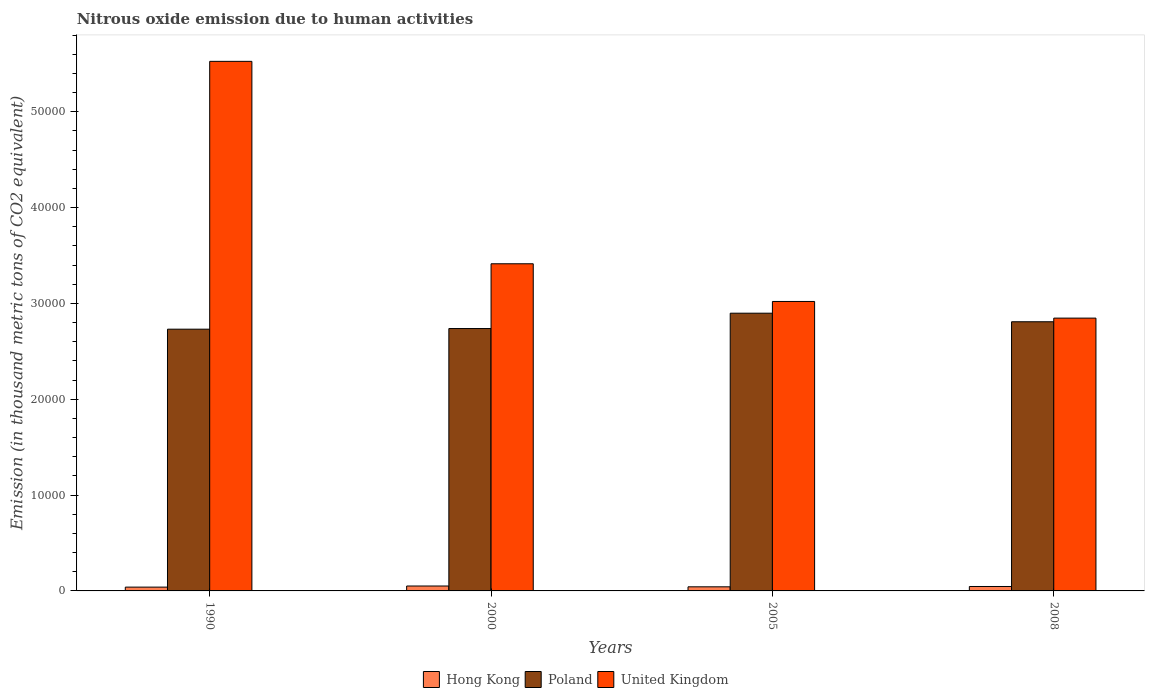How many different coloured bars are there?
Give a very brief answer. 3. Are the number of bars per tick equal to the number of legend labels?
Provide a short and direct response. Yes. Are the number of bars on each tick of the X-axis equal?
Offer a terse response. Yes. What is the label of the 3rd group of bars from the left?
Keep it short and to the point. 2005. What is the amount of nitrous oxide emitted in Hong Kong in 2008?
Your answer should be very brief. 462.8. Across all years, what is the maximum amount of nitrous oxide emitted in Hong Kong?
Make the answer very short. 513.2. Across all years, what is the minimum amount of nitrous oxide emitted in Hong Kong?
Provide a succinct answer. 396.9. In which year was the amount of nitrous oxide emitted in United Kingdom maximum?
Your answer should be compact. 1990. What is the total amount of nitrous oxide emitted in Hong Kong in the graph?
Your answer should be compact. 1801.1. What is the difference between the amount of nitrous oxide emitted in Hong Kong in 1990 and that in 2000?
Keep it short and to the point. -116.3. What is the difference between the amount of nitrous oxide emitted in Hong Kong in 2000 and the amount of nitrous oxide emitted in Poland in 1990?
Provide a succinct answer. -2.68e+04. What is the average amount of nitrous oxide emitted in Hong Kong per year?
Provide a succinct answer. 450.27. In the year 2005, what is the difference between the amount of nitrous oxide emitted in Hong Kong and amount of nitrous oxide emitted in United Kingdom?
Keep it short and to the point. -2.98e+04. In how many years, is the amount of nitrous oxide emitted in Poland greater than 22000 thousand metric tons?
Make the answer very short. 4. What is the ratio of the amount of nitrous oxide emitted in Poland in 1990 to that in 2005?
Offer a terse response. 0.94. Is the difference between the amount of nitrous oxide emitted in Hong Kong in 1990 and 2008 greater than the difference between the amount of nitrous oxide emitted in United Kingdom in 1990 and 2008?
Provide a succinct answer. No. What is the difference between the highest and the second highest amount of nitrous oxide emitted in Hong Kong?
Offer a terse response. 50.4. What is the difference between the highest and the lowest amount of nitrous oxide emitted in Poland?
Give a very brief answer. 1667.4. Is the sum of the amount of nitrous oxide emitted in Hong Kong in 1990 and 2000 greater than the maximum amount of nitrous oxide emitted in United Kingdom across all years?
Give a very brief answer. No. What does the 1st bar from the left in 2008 represents?
Make the answer very short. Hong Kong. What does the 3rd bar from the right in 2000 represents?
Ensure brevity in your answer.  Hong Kong. Are all the bars in the graph horizontal?
Provide a succinct answer. No. What is the difference between two consecutive major ticks on the Y-axis?
Keep it short and to the point. 10000. Does the graph contain any zero values?
Make the answer very short. No. Where does the legend appear in the graph?
Keep it short and to the point. Bottom center. What is the title of the graph?
Provide a succinct answer. Nitrous oxide emission due to human activities. Does "Pacific island small states" appear as one of the legend labels in the graph?
Keep it short and to the point. No. What is the label or title of the Y-axis?
Your answer should be compact. Emission (in thousand metric tons of CO2 equivalent). What is the Emission (in thousand metric tons of CO2 equivalent) of Hong Kong in 1990?
Provide a succinct answer. 396.9. What is the Emission (in thousand metric tons of CO2 equivalent) of Poland in 1990?
Your answer should be compact. 2.73e+04. What is the Emission (in thousand metric tons of CO2 equivalent) in United Kingdom in 1990?
Ensure brevity in your answer.  5.53e+04. What is the Emission (in thousand metric tons of CO2 equivalent) of Hong Kong in 2000?
Keep it short and to the point. 513.2. What is the Emission (in thousand metric tons of CO2 equivalent) in Poland in 2000?
Give a very brief answer. 2.74e+04. What is the Emission (in thousand metric tons of CO2 equivalent) of United Kingdom in 2000?
Your answer should be very brief. 3.41e+04. What is the Emission (in thousand metric tons of CO2 equivalent) in Hong Kong in 2005?
Give a very brief answer. 428.2. What is the Emission (in thousand metric tons of CO2 equivalent) in Poland in 2005?
Ensure brevity in your answer.  2.90e+04. What is the Emission (in thousand metric tons of CO2 equivalent) of United Kingdom in 2005?
Provide a succinct answer. 3.02e+04. What is the Emission (in thousand metric tons of CO2 equivalent) of Hong Kong in 2008?
Provide a succinct answer. 462.8. What is the Emission (in thousand metric tons of CO2 equivalent) of Poland in 2008?
Keep it short and to the point. 2.81e+04. What is the Emission (in thousand metric tons of CO2 equivalent) in United Kingdom in 2008?
Give a very brief answer. 2.85e+04. Across all years, what is the maximum Emission (in thousand metric tons of CO2 equivalent) in Hong Kong?
Make the answer very short. 513.2. Across all years, what is the maximum Emission (in thousand metric tons of CO2 equivalent) in Poland?
Offer a terse response. 2.90e+04. Across all years, what is the maximum Emission (in thousand metric tons of CO2 equivalent) in United Kingdom?
Make the answer very short. 5.53e+04. Across all years, what is the minimum Emission (in thousand metric tons of CO2 equivalent) of Hong Kong?
Your answer should be very brief. 396.9. Across all years, what is the minimum Emission (in thousand metric tons of CO2 equivalent) in Poland?
Give a very brief answer. 2.73e+04. Across all years, what is the minimum Emission (in thousand metric tons of CO2 equivalent) of United Kingdom?
Ensure brevity in your answer.  2.85e+04. What is the total Emission (in thousand metric tons of CO2 equivalent) in Hong Kong in the graph?
Your answer should be compact. 1801.1. What is the total Emission (in thousand metric tons of CO2 equivalent) of Poland in the graph?
Make the answer very short. 1.12e+05. What is the total Emission (in thousand metric tons of CO2 equivalent) in United Kingdom in the graph?
Your response must be concise. 1.48e+05. What is the difference between the Emission (in thousand metric tons of CO2 equivalent) of Hong Kong in 1990 and that in 2000?
Offer a very short reply. -116.3. What is the difference between the Emission (in thousand metric tons of CO2 equivalent) of Poland in 1990 and that in 2000?
Offer a very short reply. -66.8. What is the difference between the Emission (in thousand metric tons of CO2 equivalent) in United Kingdom in 1990 and that in 2000?
Your answer should be compact. 2.11e+04. What is the difference between the Emission (in thousand metric tons of CO2 equivalent) in Hong Kong in 1990 and that in 2005?
Offer a very short reply. -31.3. What is the difference between the Emission (in thousand metric tons of CO2 equivalent) in Poland in 1990 and that in 2005?
Keep it short and to the point. -1667.4. What is the difference between the Emission (in thousand metric tons of CO2 equivalent) in United Kingdom in 1990 and that in 2005?
Your response must be concise. 2.51e+04. What is the difference between the Emission (in thousand metric tons of CO2 equivalent) of Hong Kong in 1990 and that in 2008?
Provide a short and direct response. -65.9. What is the difference between the Emission (in thousand metric tons of CO2 equivalent) in Poland in 1990 and that in 2008?
Give a very brief answer. -773.9. What is the difference between the Emission (in thousand metric tons of CO2 equivalent) in United Kingdom in 1990 and that in 2008?
Provide a succinct answer. 2.68e+04. What is the difference between the Emission (in thousand metric tons of CO2 equivalent) in Poland in 2000 and that in 2005?
Your answer should be very brief. -1600.6. What is the difference between the Emission (in thousand metric tons of CO2 equivalent) of United Kingdom in 2000 and that in 2005?
Keep it short and to the point. 3932.5. What is the difference between the Emission (in thousand metric tons of CO2 equivalent) of Hong Kong in 2000 and that in 2008?
Offer a terse response. 50.4. What is the difference between the Emission (in thousand metric tons of CO2 equivalent) of Poland in 2000 and that in 2008?
Offer a terse response. -707.1. What is the difference between the Emission (in thousand metric tons of CO2 equivalent) in United Kingdom in 2000 and that in 2008?
Offer a very short reply. 5669.2. What is the difference between the Emission (in thousand metric tons of CO2 equivalent) in Hong Kong in 2005 and that in 2008?
Provide a succinct answer. -34.6. What is the difference between the Emission (in thousand metric tons of CO2 equivalent) in Poland in 2005 and that in 2008?
Your response must be concise. 893.5. What is the difference between the Emission (in thousand metric tons of CO2 equivalent) of United Kingdom in 2005 and that in 2008?
Offer a very short reply. 1736.7. What is the difference between the Emission (in thousand metric tons of CO2 equivalent) of Hong Kong in 1990 and the Emission (in thousand metric tons of CO2 equivalent) of Poland in 2000?
Your answer should be compact. -2.70e+04. What is the difference between the Emission (in thousand metric tons of CO2 equivalent) of Hong Kong in 1990 and the Emission (in thousand metric tons of CO2 equivalent) of United Kingdom in 2000?
Provide a succinct answer. -3.37e+04. What is the difference between the Emission (in thousand metric tons of CO2 equivalent) in Poland in 1990 and the Emission (in thousand metric tons of CO2 equivalent) in United Kingdom in 2000?
Make the answer very short. -6823.5. What is the difference between the Emission (in thousand metric tons of CO2 equivalent) of Hong Kong in 1990 and the Emission (in thousand metric tons of CO2 equivalent) of Poland in 2005?
Give a very brief answer. -2.86e+04. What is the difference between the Emission (in thousand metric tons of CO2 equivalent) in Hong Kong in 1990 and the Emission (in thousand metric tons of CO2 equivalent) in United Kingdom in 2005?
Provide a succinct answer. -2.98e+04. What is the difference between the Emission (in thousand metric tons of CO2 equivalent) in Poland in 1990 and the Emission (in thousand metric tons of CO2 equivalent) in United Kingdom in 2005?
Offer a terse response. -2891. What is the difference between the Emission (in thousand metric tons of CO2 equivalent) of Hong Kong in 1990 and the Emission (in thousand metric tons of CO2 equivalent) of Poland in 2008?
Offer a terse response. -2.77e+04. What is the difference between the Emission (in thousand metric tons of CO2 equivalent) of Hong Kong in 1990 and the Emission (in thousand metric tons of CO2 equivalent) of United Kingdom in 2008?
Your answer should be very brief. -2.81e+04. What is the difference between the Emission (in thousand metric tons of CO2 equivalent) of Poland in 1990 and the Emission (in thousand metric tons of CO2 equivalent) of United Kingdom in 2008?
Keep it short and to the point. -1154.3. What is the difference between the Emission (in thousand metric tons of CO2 equivalent) in Hong Kong in 2000 and the Emission (in thousand metric tons of CO2 equivalent) in Poland in 2005?
Provide a succinct answer. -2.85e+04. What is the difference between the Emission (in thousand metric tons of CO2 equivalent) in Hong Kong in 2000 and the Emission (in thousand metric tons of CO2 equivalent) in United Kingdom in 2005?
Provide a succinct answer. -2.97e+04. What is the difference between the Emission (in thousand metric tons of CO2 equivalent) in Poland in 2000 and the Emission (in thousand metric tons of CO2 equivalent) in United Kingdom in 2005?
Offer a very short reply. -2824.2. What is the difference between the Emission (in thousand metric tons of CO2 equivalent) of Hong Kong in 2000 and the Emission (in thousand metric tons of CO2 equivalent) of Poland in 2008?
Provide a short and direct response. -2.76e+04. What is the difference between the Emission (in thousand metric tons of CO2 equivalent) in Hong Kong in 2000 and the Emission (in thousand metric tons of CO2 equivalent) in United Kingdom in 2008?
Provide a short and direct response. -2.79e+04. What is the difference between the Emission (in thousand metric tons of CO2 equivalent) of Poland in 2000 and the Emission (in thousand metric tons of CO2 equivalent) of United Kingdom in 2008?
Offer a very short reply. -1087.5. What is the difference between the Emission (in thousand metric tons of CO2 equivalent) in Hong Kong in 2005 and the Emission (in thousand metric tons of CO2 equivalent) in Poland in 2008?
Your response must be concise. -2.77e+04. What is the difference between the Emission (in thousand metric tons of CO2 equivalent) of Hong Kong in 2005 and the Emission (in thousand metric tons of CO2 equivalent) of United Kingdom in 2008?
Your response must be concise. -2.80e+04. What is the difference between the Emission (in thousand metric tons of CO2 equivalent) in Poland in 2005 and the Emission (in thousand metric tons of CO2 equivalent) in United Kingdom in 2008?
Your answer should be compact. 513.1. What is the average Emission (in thousand metric tons of CO2 equivalent) in Hong Kong per year?
Give a very brief answer. 450.27. What is the average Emission (in thousand metric tons of CO2 equivalent) of Poland per year?
Give a very brief answer. 2.79e+04. What is the average Emission (in thousand metric tons of CO2 equivalent) of United Kingdom per year?
Offer a terse response. 3.70e+04. In the year 1990, what is the difference between the Emission (in thousand metric tons of CO2 equivalent) in Hong Kong and Emission (in thousand metric tons of CO2 equivalent) in Poland?
Your answer should be very brief. -2.69e+04. In the year 1990, what is the difference between the Emission (in thousand metric tons of CO2 equivalent) of Hong Kong and Emission (in thousand metric tons of CO2 equivalent) of United Kingdom?
Ensure brevity in your answer.  -5.49e+04. In the year 1990, what is the difference between the Emission (in thousand metric tons of CO2 equivalent) of Poland and Emission (in thousand metric tons of CO2 equivalent) of United Kingdom?
Your response must be concise. -2.79e+04. In the year 2000, what is the difference between the Emission (in thousand metric tons of CO2 equivalent) in Hong Kong and Emission (in thousand metric tons of CO2 equivalent) in Poland?
Provide a short and direct response. -2.69e+04. In the year 2000, what is the difference between the Emission (in thousand metric tons of CO2 equivalent) of Hong Kong and Emission (in thousand metric tons of CO2 equivalent) of United Kingdom?
Make the answer very short. -3.36e+04. In the year 2000, what is the difference between the Emission (in thousand metric tons of CO2 equivalent) of Poland and Emission (in thousand metric tons of CO2 equivalent) of United Kingdom?
Provide a short and direct response. -6756.7. In the year 2005, what is the difference between the Emission (in thousand metric tons of CO2 equivalent) of Hong Kong and Emission (in thousand metric tons of CO2 equivalent) of Poland?
Your response must be concise. -2.85e+04. In the year 2005, what is the difference between the Emission (in thousand metric tons of CO2 equivalent) in Hong Kong and Emission (in thousand metric tons of CO2 equivalent) in United Kingdom?
Give a very brief answer. -2.98e+04. In the year 2005, what is the difference between the Emission (in thousand metric tons of CO2 equivalent) in Poland and Emission (in thousand metric tons of CO2 equivalent) in United Kingdom?
Provide a short and direct response. -1223.6. In the year 2008, what is the difference between the Emission (in thousand metric tons of CO2 equivalent) in Hong Kong and Emission (in thousand metric tons of CO2 equivalent) in Poland?
Keep it short and to the point. -2.76e+04. In the year 2008, what is the difference between the Emission (in thousand metric tons of CO2 equivalent) of Hong Kong and Emission (in thousand metric tons of CO2 equivalent) of United Kingdom?
Give a very brief answer. -2.80e+04. In the year 2008, what is the difference between the Emission (in thousand metric tons of CO2 equivalent) of Poland and Emission (in thousand metric tons of CO2 equivalent) of United Kingdom?
Ensure brevity in your answer.  -380.4. What is the ratio of the Emission (in thousand metric tons of CO2 equivalent) of Hong Kong in 1990 to that in 2000?
Your response must be concise. 0.77. What is the ratio of the Emission (in thousand metric tons of CO2 equivalent) in Poland in 1990 to that in 2000?
Offer a very short reply. 1. What is the ratio of the Emission (in thousand metric tons of CO2 equivalent) of United Kingdom in 1990 to that in 2000?
Your answer should be compact. 1.62. What is the ratio of the Emission (in thousand metric tons of CO2 equivalent) in Hong Kong in 1990 to that in 2005?
Your response must be concise. 0.93. What is the ratio of the Emission (in thousand metric tons of CO2 equivalent) of Poland in 1990 to that in 2005?
Your answer should be very brief. 0.94. What is the ratio of the Emission (in thousand metric tons of CO2 equivalent) of United Kingdom in 1990 to that in 2005?
Make the answer very short. 1.83. What is the ratio of the Emission (in thousand metric tons of CO2 equivalent) of Hong Kong in 1990 to that in 2008?
Give a very brief answer. 0.86. What is the ratio of the Emission (in thousand metric tons of CO2 equivalent) of Poland in 1990 to that in 2008?
Your answer should be very brief. 0.97. What is the ratio of the Emission (in thousand metric tons of CO2 equivalent) of United Kingdom in 1990 to that in 2008?
Your answer should be compact. 1.94. What is the ratio of the Emission (in thousand metric tons of CO2 equivalent) in Hong Kong in 2000 to that in 2005?
Offer a terse response. 1.2. What is the ratio of the Emission (in thousand metric tons of CO2 equivalent) in Poland in 2000 to that in 2005?
Provide a short and direct response. 0.94. What is the ratio of the Emission (in thousand metric tons of CO2 equivalent) in United Kingdom in 2000 to that in 2005?
Your answer should be compact. 1.13. What is the ratio of the Emission (in thousand metric tons of CO2 equivalent) of Hong Kong in 2000 to that in 2008?
Your answer should be very brief. 1.11. What is the ratio of the Emission (in thousand metric tons of CO2 equivalent) of Poland in 2000 to that in 2008?
Provide a succinct answer. 0.97. What is the ratio of the Emission (in thousand metric tons of CO2 equivalent) in United Kingdom in 2000 to that in 2008?
Make the answer very short. 1.2. What is the ratio of the Emission (in thousand metric tons of CO2 equivalent) in Hong Kong in 2005 to that in 2008?
Your answer should be compact. 0.93. What is the ratio of the Emission (in thousand metric tons of CO2 equivalent) of Poland in 2005 to that in 2008?
Ensure brevity in your answer.  1.03. What is the ratio of the Emission (in thousand metric tons of CO2 equivalent) in United Kingdom in 2005 to that in 2008?
Offer a terse response. 1.06. What is the difference between the highest and the second highest Emission (in thousand metric tons of CO2 equivalent) of Hong Kong?
Offer a very short reply. 50.4. What is the difference between the highest and the second highest Emission (in thousand metric tons of CO2 equivalent) of Poland?
Your response must be concise. 893.5. What is the difference between the highest and the second highest Emission (in thousand metric tons of CO2 equivalent) in United Kingdom?
Keep it short and to the point. 2.11e+04. What is the difference between the highest and the lowest Emission (in thousand metric tons of CO2 equivalent) of Hong Kong?
Keep it short and to the point. 116.3. What is the difference between the highest and the lowest Emission (in thousand metric tons of CO2 equivalent) in Poland?
Ensure brevity in your answer.  1667.4. What is the difference between the highest and the lowest Emission (in thousand metric tons of CO2 equivalent) of United Kingdom?
Ensure brevity in your answer.  2.68e+04. 